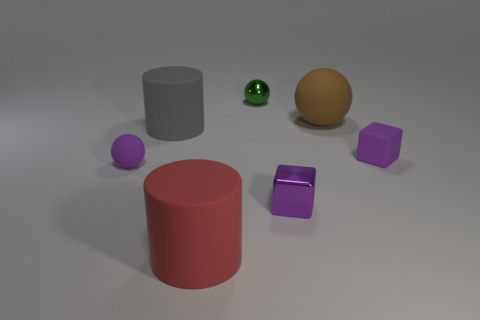Subtract all purple spheres. Subtract all yellow cylinders. How many spheres are left? 2 Add 1 large gray rubber things. How many objects exist? 8 Subtract all balls. How many objects are left? 4 Subtract 0 cyan cylinders. How many objects are left? 7 Subtract all small yellow metallic spheres. Subtract all large matte spheres. How many objects are left? 6 Add 6 purple matte things. How many purple matte things are left? 8 Add 5 large brown shiny spheres. How many large brown shiny spheres exist? 5 